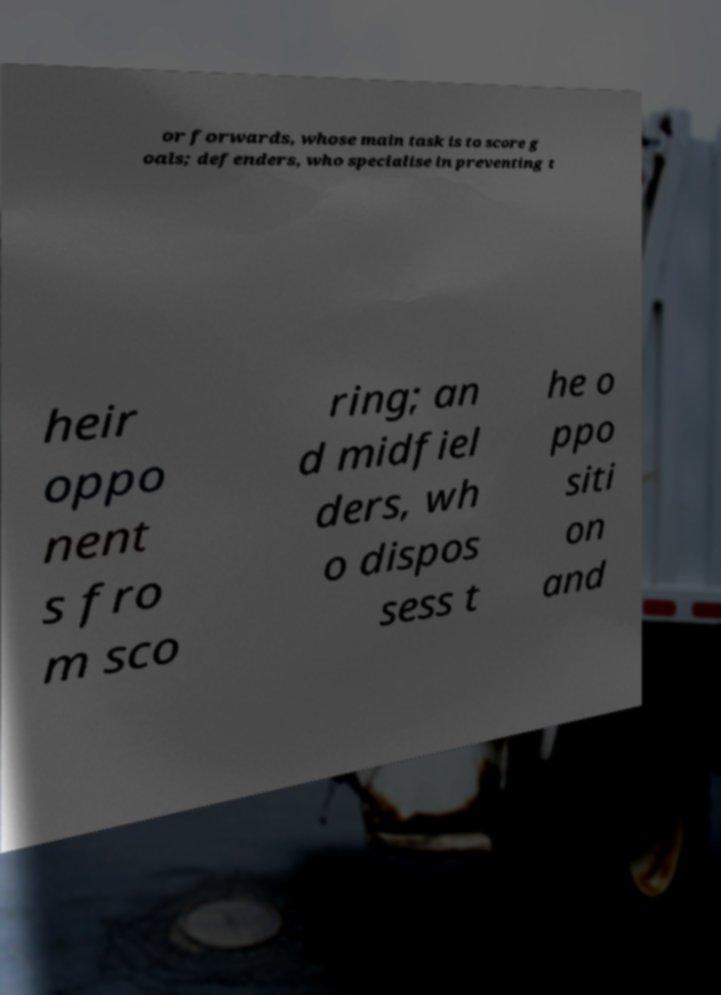Could you assist in decoding the text presented in this image and type it out clearly? or forwards, whose main task is to score g oals; defenders, who specialise in preventing t heir oppo nent s fro m sco ring; an d midfiel ders, wh o dispos sess t he o ppo siti on and 